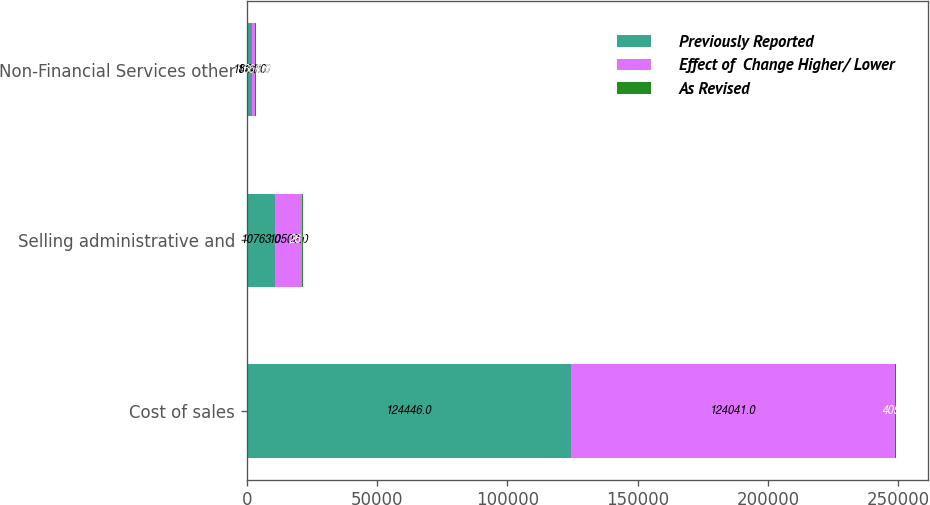Convert chart. <chart><loc_0><loc_0><loc_500><loc_500><stacked_bar_chart><ecel><fcel>Cost of sales<fcel>Selling administrative and<fcel>Non-Financial Services other<nl><fcel>Previously Reported<fcel>124446<fcel>10763<fcel>1854<nl><fcel>Effect of  Change Higher/ Lower<fcel>124041<fcel>10502<fcel>1188<nl><fcel>As Revised<fcel>405<fcel>261<fcel>666<nl></chart> 